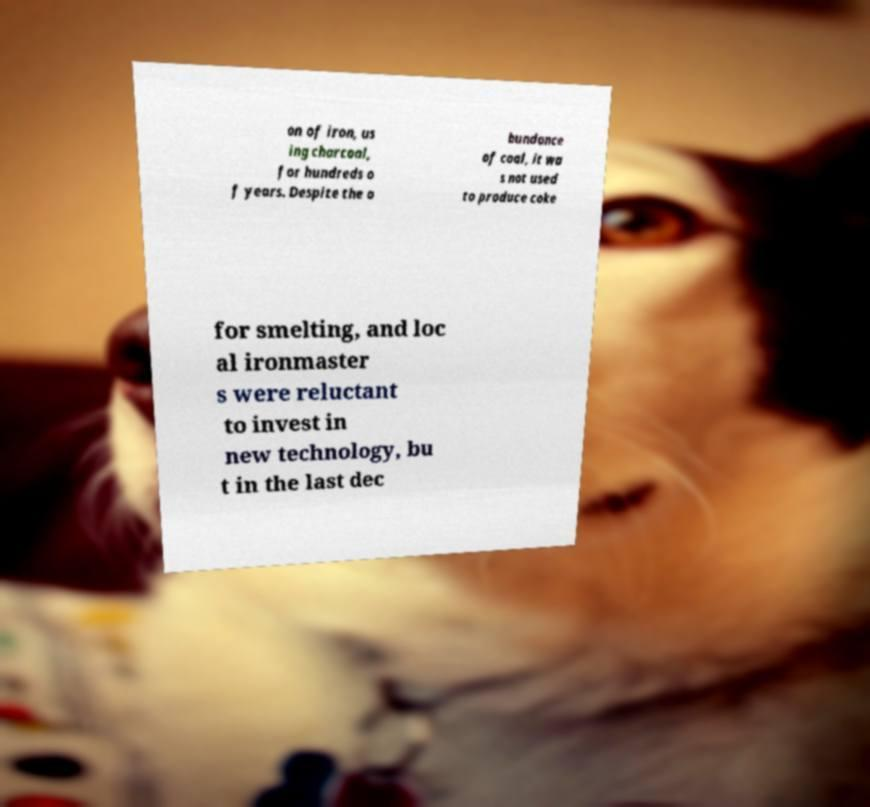Please identify and transcribe the text found in this image. on of iron, us ing charcoal, for hundreds o f years. Despite the a bundance of coal, it wa s not used to produce coke for smelting, and loc al ironmaster s were reluctant to invest in new technology, bu t in the last dec 